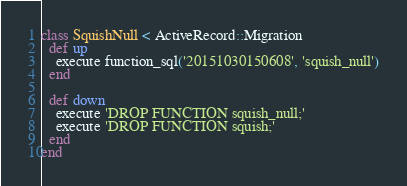<code> <loc_0><loc_0><loc_500><loc_500><_Ruby_>class SquishNull < ActiveRecord::Migration
  def up
    execute function_sql('20151030150608', 'squish_null')
  end

  def down
    execute 'DROP FUNCTION squish_null;'
    execute 'DROP FUNCTION squish;'
  end
end
</code> 